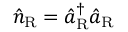<formula> <loc_0><loc_0><loc_500><loc_500>\hat { n } _ { R } = \hat { a } _ { R } ^ { \dagger } \hat { a } _ { R }</formula> 